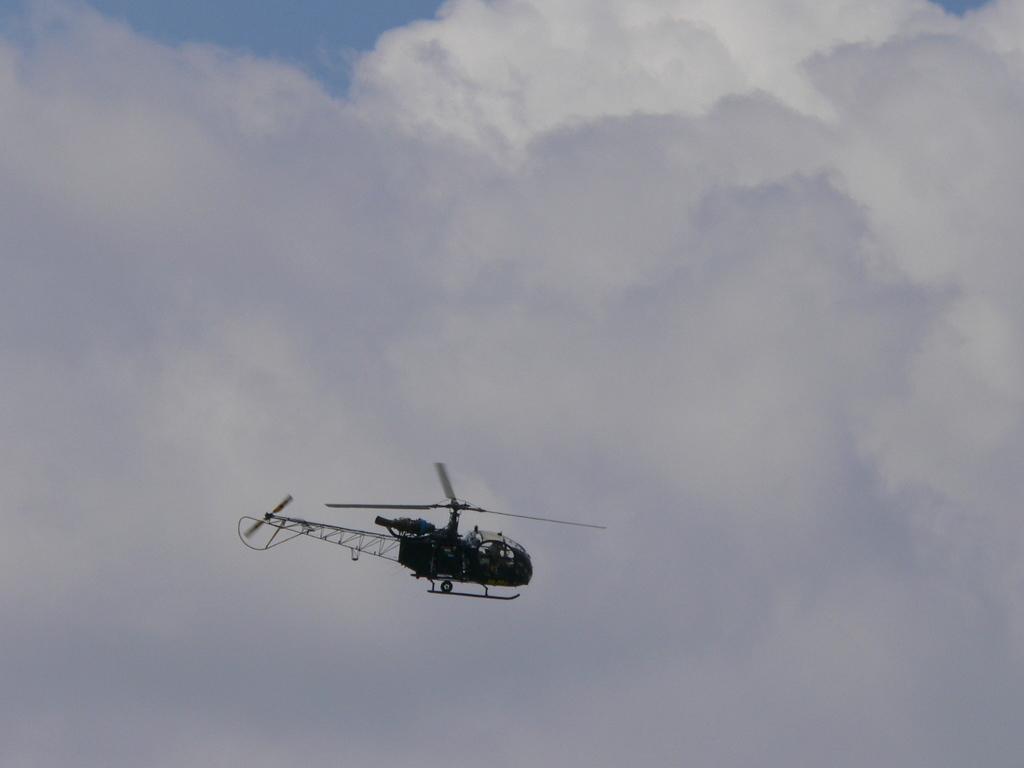Can you describe this image briefly? In this image a helicopter is flying in the sky. The sky is cloudy. 